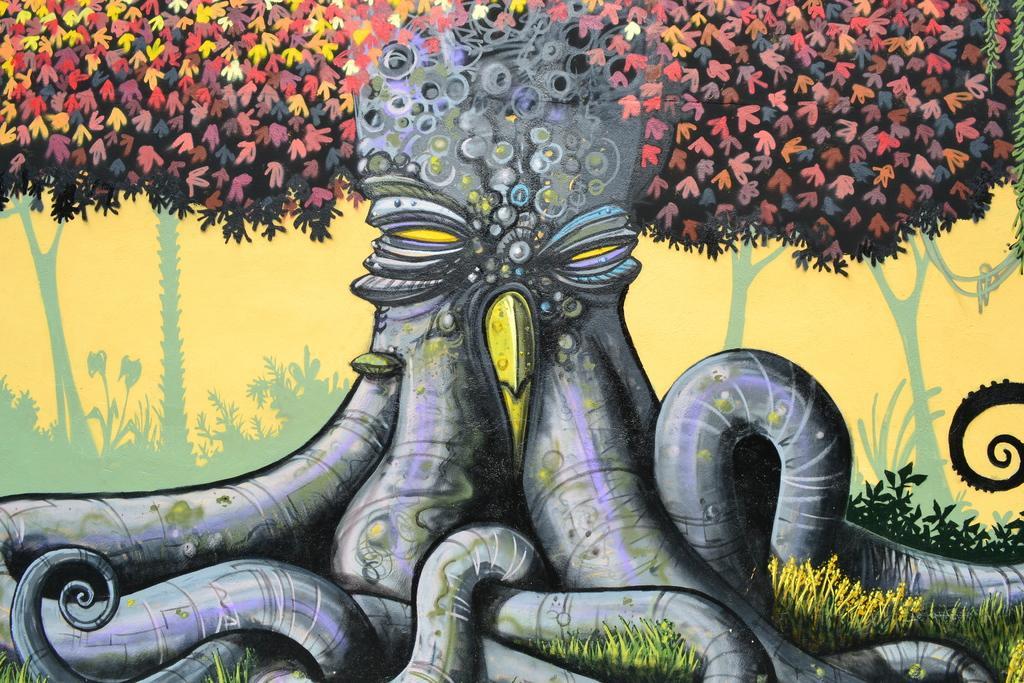In one or two sentences, can you explain what this image depicts? In this image we can see a painting of a tree. 